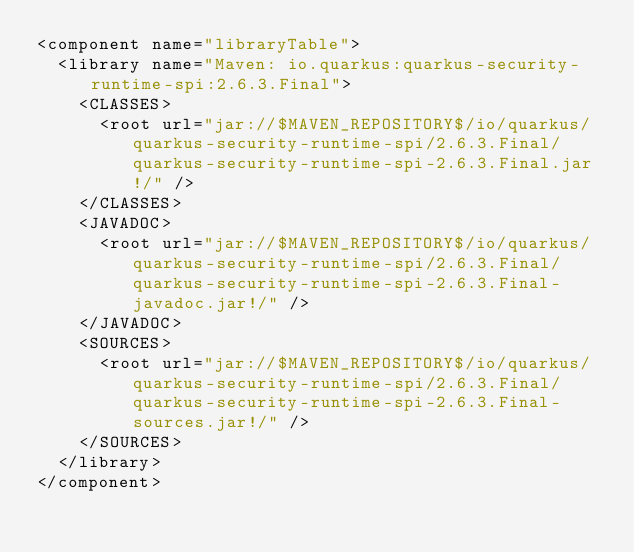Convert code to text. <code><loc_0><loc_0><loc_500><loc_500><_XML_><component name="libraryTable">
  <library name="Maven: io.quarkus:quarkus-security-runtime-spi:2.6.3.Final">
    <CLASSES>
      <root url="jar://$MAVEN_REPOSITORY$/io/quarkus/quarkus-security-runtime-spi/2.6.3.Final/quarkus-security-runtime-spi-2.6.3.Final.jar!/" />
    </CLASSES>
    <JAVADOC>
      <root url="jar://$MAVEN_REPOSITORY$/io/quarkus/quarkus-security-runtime-spi/2.6.3.Final/quarkus-security-runtime-spi-2.6.3.Final-javadoc.jar!/" />
    </JAVADOC>
    <SOURCES>
      <root url="jar://$MAVEN_REPOSITORY$/io/quarkus/quarkus-security-runtime-spi/2.6.3.Final/quarkus-security-runtime-spi-2.6.3.Final-sources.jar!/" />
    </SOURCES>
  </library>
</component></code> 